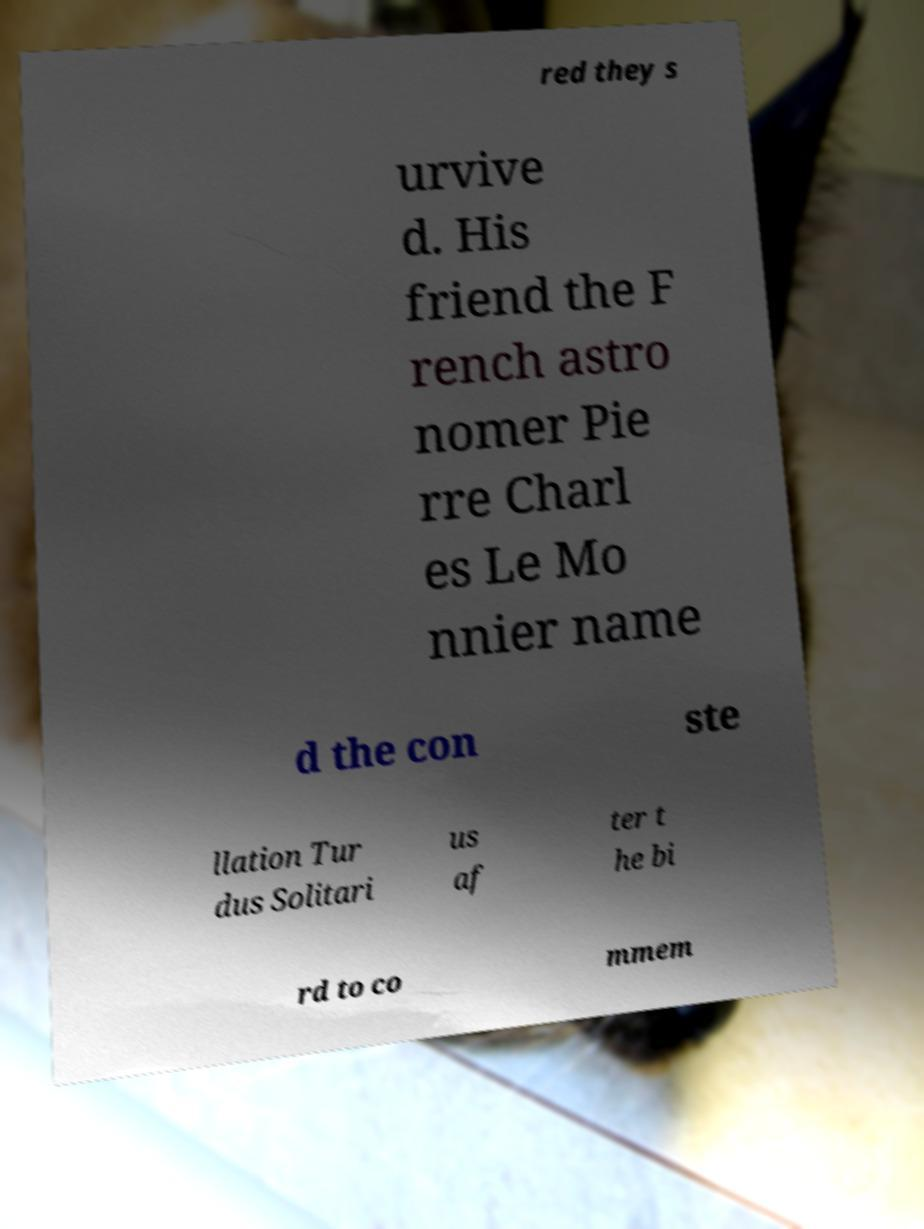Can you read and provide the text displayed in the image?This photo seems to have some interesting text. Can you extract and type it out for me? red they s urvive d. His friend the F rench astro nomer Pie rre Charl es Le Mo nnier name d the con ste llation Tur dus Solitari us af ter t he bi rd to co mmem 